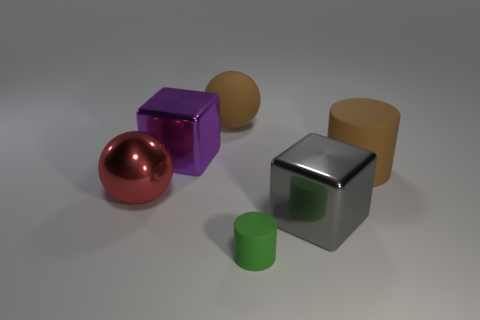What number of cylinders are the same size as the gray metal cube?
Your answer should be very brief. 1. What color is the big rubber thing to the right of the brown rubber thing behind the large brown rubber cylinder?
Your response must be concise. Brown. Is there a tiny blue cylinder?
Your answer should be compact. No. Is the purple shiny object the same shape as the green rubber object?
Ensure brevity in your answer.  No. There is a rubber cylinder that is the same color as the matte sphere; what is its size?
Keep it short and to the point. Large. What number of tiny green things are to the left of the matte thing to the right of the small green rubber thing?
Your response must be concise. 1. What number of large shiny objects are right of the large red object and behind the large gray metal block?
Make the answer very short. 1. What number of objects are tiny cylinders or rubber objects that are behind the green cylinder?
Your answer should be compact. 3. The green object that is the same material as the brown sphere is what size?
Give a very brief answer. Small. There is a brown matte object to the left of the cube right of the matte ball; what is its shape?
Make the answer very short. Sphere. 